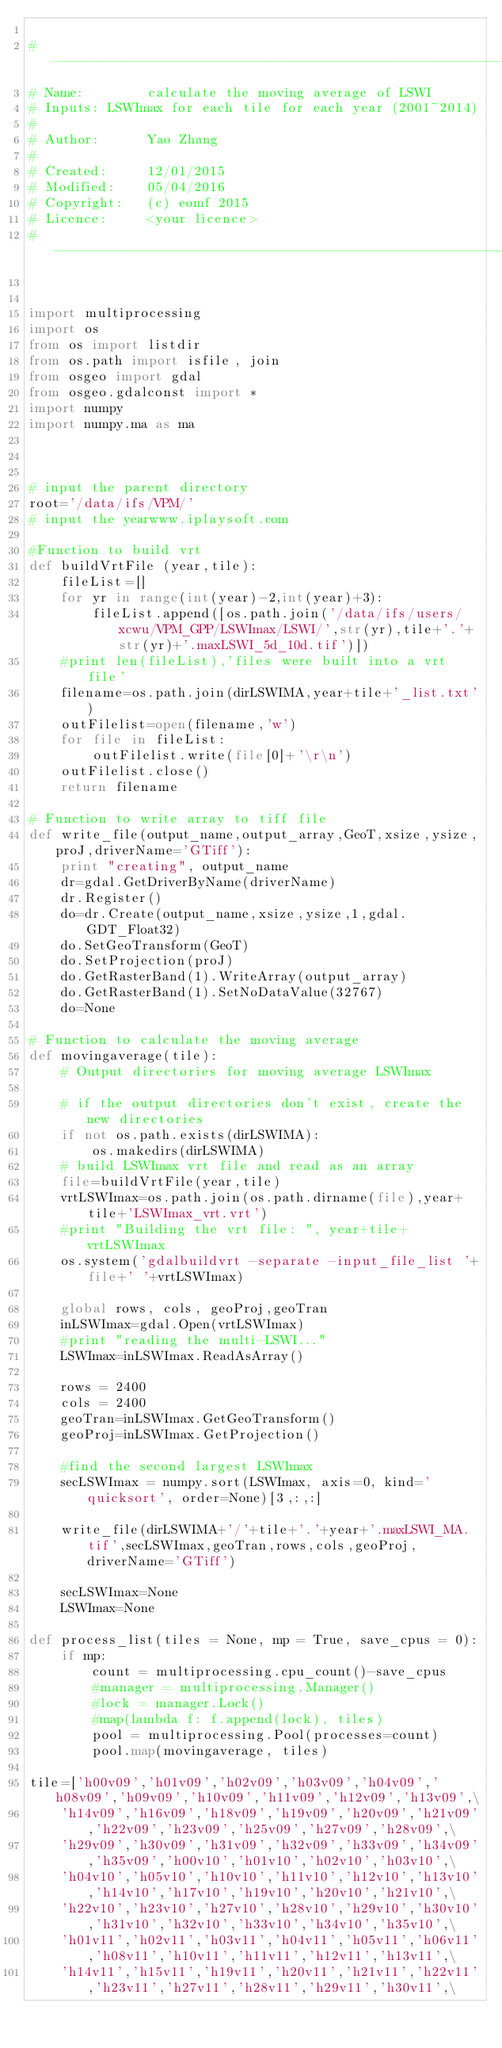<code> <loc_0><loc_0><loc_500><loc_500><_Python_>
#-------------------------------------------------------------------------------
# Name:        calculate the moving average of LSWI
# Inputs: LSWImax for each tile for each year (2001~2014)
#
# Author:      Yao Zhang
#
# Created:     12/01/2015
# Modified:    05/04/2016
# Copyright:   (c) eomf 2015
# Licence:     <your licence>
#-------------------------------------------------------------------------------


import multiprocessing
import os
from os import listdir
from os.path import isfile, join
from osgeo import gdal
from osgeo.gdalconst import *
import numpy
import numpy.ma as ma



# input the parent directory
root='/data/ifs/VPM/'
# input the yearwww.iplaysoft.com

#Function to build vrt
def buildVrtFile (year,tile):
    fileList=[]
    for yr in range(int(year)-2,int(year)+3):
        fileList.append([os.path.join('/data/ifs/users/xcwu/VPM_GPP/LSWImax/LSWI/',str(yr),tile+'.'+str(yr)+'.maxLSWI_5d_10d.tif')])
    #print len(fileList),'files were built into a vrt file'
    filename=os.path.join(dirLSWIMA,year+tile+'_list.txt')
    outFilelist=open(filename,'w')
    for file in fileList:
        outFilelist.write(file[0]+'\r\n')
    outFilelist.close()
    return filename

# Function to write array to tiff file
def write_file(output_name,output_array,GeoT,xsize,ysize,proJ,driverName='GTiff'):
    print "creating", output_name
    dr=gdal.GetDriverByName(driverName)
    dr.Register()
    do=dr.Create(output_name,xsize,ysize,1,gdal.GDT_Float32)
    do.SetGeoTransform(GeoT)
    do.SetProjection(proJ)
    do.GetRasterBand(1).WriteArray(output_array)
    do.GetRasterBand(1).SetNoDataValue(32767)
    do=None

# Function to calculate the moving average
def movingaverage(tile):
    # Output directories for moving average LSWImax
 
    # if the output directories don't exist, create the new directories
    if not os.path.exists(dirLSWIMA):
        os.makedirs(dirLSWIMA)
    # build LSWImax vrt file and read as an array
    file=buildVrtFile(year,tile)
    vrtLSWImax=os.path.join(os.path.dirname(file),year+tile+'LSWImax_vrt.vrt')
    #print "Building the vrt file: ", year+tile+vrtLSWImax
    os.system('gdalbuildvrt -separate -input_file_list '+file+' '+vrtLSWImax)
    
    global rows, cols, geoProj,geoTran
    inLSWImax=gdal.Open(vrtLSWImax)
    #print "reading the multi-LSWI..."
    LSWImax=inLSWImax.ReadAsArray()

    rows = 2400
    cols = 2400
    geoTran=inLSWImax.GetGeoTransform()
    geoProj=inLSWImax.GetProjection()
    
    #find the second largest LSWImax
    secLSWImax = numpy.sort(LSWImax, axis=0, kind='quicksort', order=None)[3,:,:]
    
    write_file(dirLSWIMA+'/'+tile+'.'+year+'.maxLSWI_MA.tif',secLSWImax,geoTran,rows,cols,geoProj,driverName='GTiff')
    
    secLSWImax=None
    LSWImax=None
 
def process_list(tiles = None, mp = True, save_cpus = 0):    
    if mp:
        count = multiprocessing.cpu_count()-save_cpus
        #manager = multiprocessing.Manager()
        #lock = manager.Lock()
        #map(lambda f: f.append(lock), tiles)
        pool = multiprocessing.Pool(processes=count)
        pool.map(movingaverage, tiles)

tile=['h00v09','h01v09','h02v09','h03v09','h04v09','h08v09','h09v09','h10v09','h11v09','h12v09','h13v09',\
    'h14v09','h16v09','h18v09','h19v09','h20v09','h21v09','h22v09','h23v09','h25v09','h27v09','h28v09',\
    'h29v09','h30v09','h31v09','h32v09','h33v09','h34v09','h35v09','h00v10','h01v10','h02v10','h03v10',\
    'h04v10','h05v10','h10v10','h11v10','h12v10','h13v10','h14v10','h17v10','h19v10','h20v10','h21v10',\
    'h22v10','h23v10','h27v10','h28v10','h29v10','h30v10','h31v10','h32v10','h33v10','h34v10','h35v10',\
    'h01v11','h02v11','h03v11','h04v11','h05v11','h06v11','h08v11','h10v11','h11v11','h12v11','h13v11',\
    'h14v11','h15v11','h19v11','h20v11','h21v11','h22v11','h23v11','h27v11','h28v11','h29v11','h30v11',\</code> 